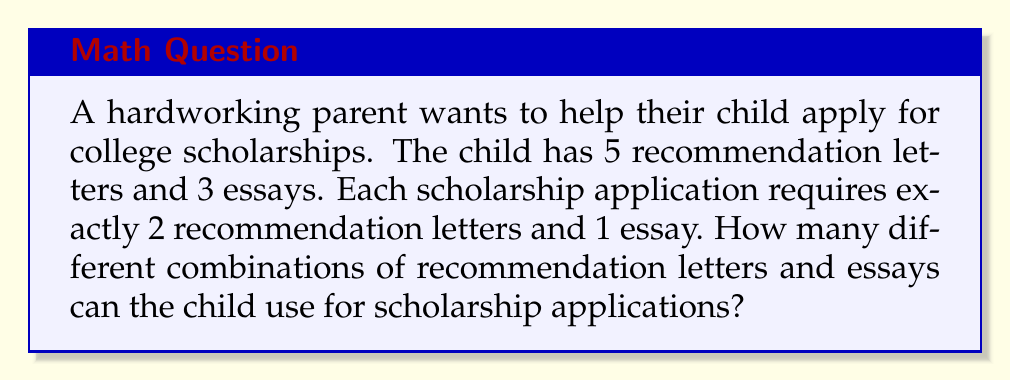Help me with this question. Let's break this down step-by-step:

1) First, we need to choose 2 recommendation letters out of 5. This is a combination problem, denoted as $\binom{5}{2}$ or $C(5,2)$.

   $\binom{5}{2} = \frac{5!}{2!(5-2)!} = \frac{5!}{2!3!} = 10$

2) Next, we need to choose 1 essay out of 3. This is simply $\binom{3}{1}$ or $C(3,1)$.

   $\binom{3}{1} = \frac{3!}{1!(3-1)!} = \frac{3!}{1!2!} = 3$

3) According to the Multiplication Principle, if we have 10 ways to choose the recommendation letters and 3 ways to choose the essay, the total number of different combinations is:

   $10 \times 3 = 30$

Therefore, the child can create 30 different combinations of recommendation letters and essays for scholarship applications.
Answer: 30 